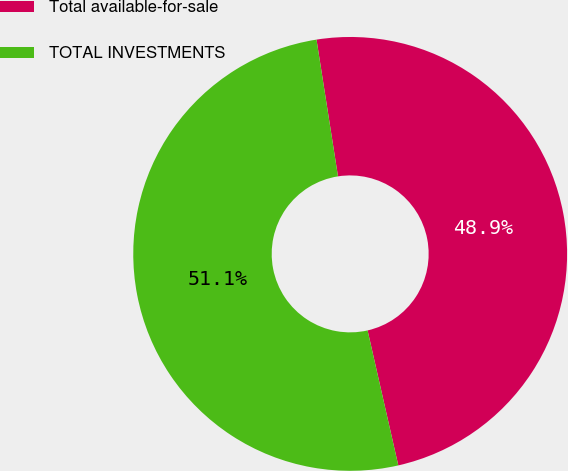Convert chart to OTSL. <chart><loc_0><loc_0><loc_500><loc_500><pie_chart><fcel>Total available-for-sale<fcel>TOTAL INVESTMENTS<nl><fcel>48.92%<fcel>51.08%<nl></chart> 